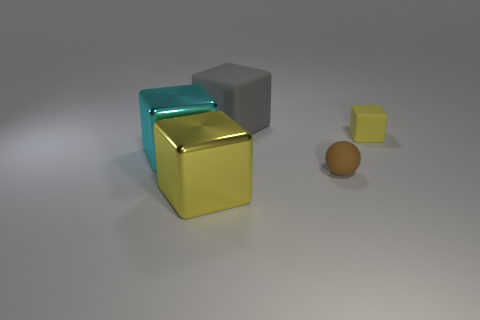Are there an equal number of small blue spheres and small brown objects?
Offer a terse response. No. What is the material of the large gray cube?
Provide a short and direct response. Rubber. What shape is the small yellow rubber thing?
Keep it short and to the point. Cube. How many objects are the same color as the tiny sphere?
Offer a very short reply. 0. What material is the yellow cube left of the matte object in front of the block that is right of the large gray matte block?
Ensure brevity in your answer.  Metal. What number of brown objects are metal things or big cylinders?
Make the answer very short. 0. How big is the metal cube that is in front of the brown matte thing that is right of the metal cube that is in front of the small ball?
Your answer should be very brief. Large. What is the size of the gray object that is the same shape as the big yellow metal object?
Offer a terse response. Large. What number of small things are red balls or gray rubber objects?
Make the answer very short. 0. Is the thing that is behind the tiny cube made of the same material as the big thing in front of the large cyan metallic thing?
Offer a very short reply. No. 